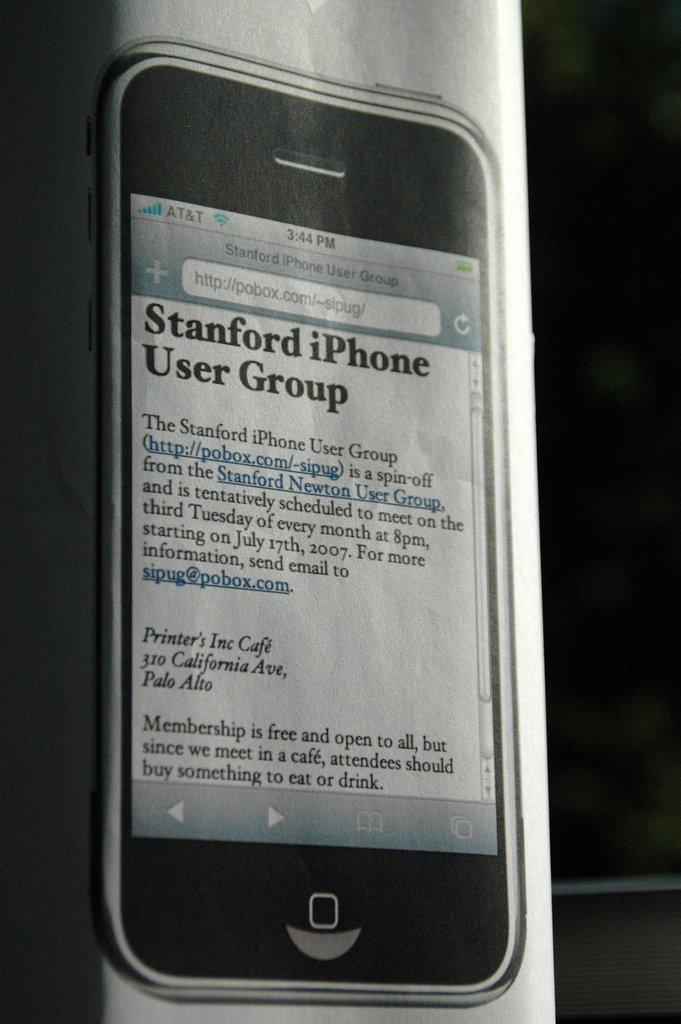<image>
Present a compact description of the photo's key features. A phone displays an article about the Stanford iPhone User Group. 